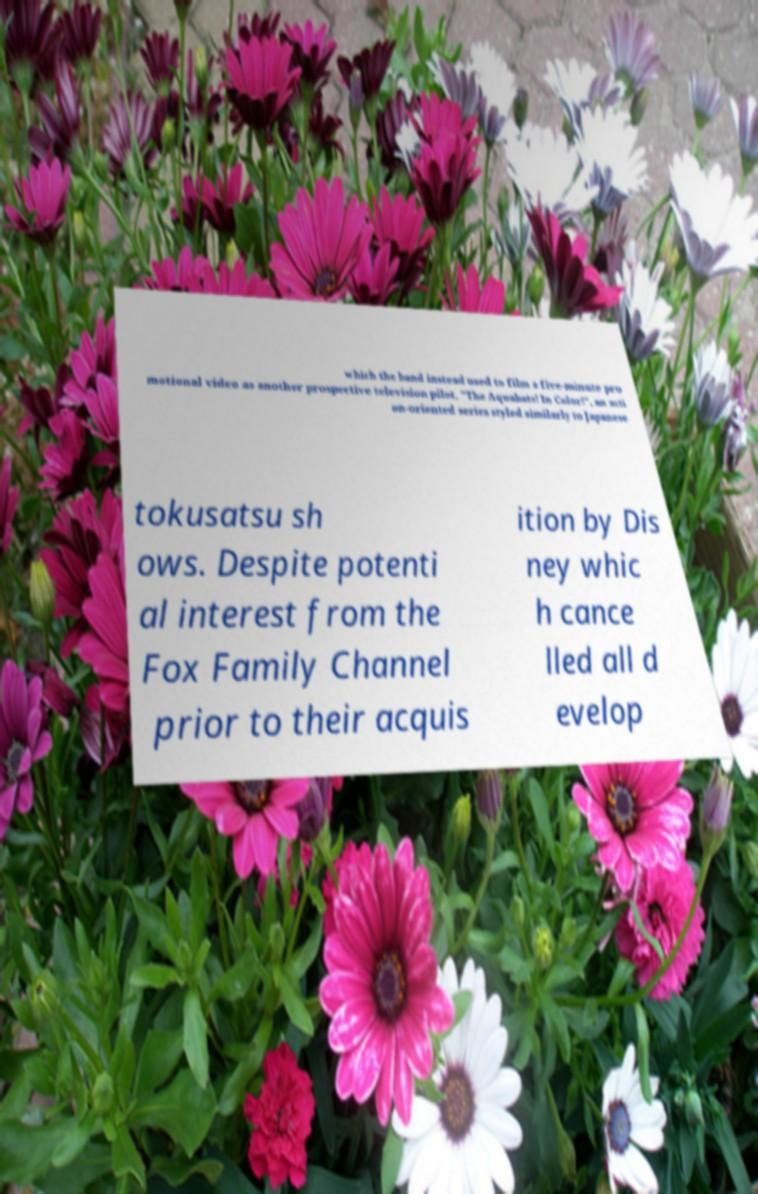Please read and relay the text visible in this image. What does it say? which the band instead used to film a five-minute pro motional video as another prospective television pilot, "The Aquabats! In Color!", an acti on-oriented series styled similarly to Japanese tokusatsu sh ows. Despite potenti al interest from the Fox Family Channel prior to their acquis ition by Dis ney whic h cance lled all d evelop 